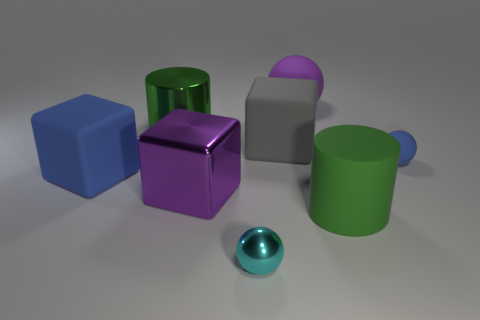What materials do the objects in the image seem to be made of? The objects in the image appear to be made of a smooth, reflective material, similar to polished metal or plastic, giving them a shiny appearance.  Are there any objects that stand out to you due to their size or color? Yes, the large purple sphere in the center of the arrangement stands out due to its size and central position. Additionally, the cyan metallic sphere is distinctive because of its vibrant color and shiny texture. 